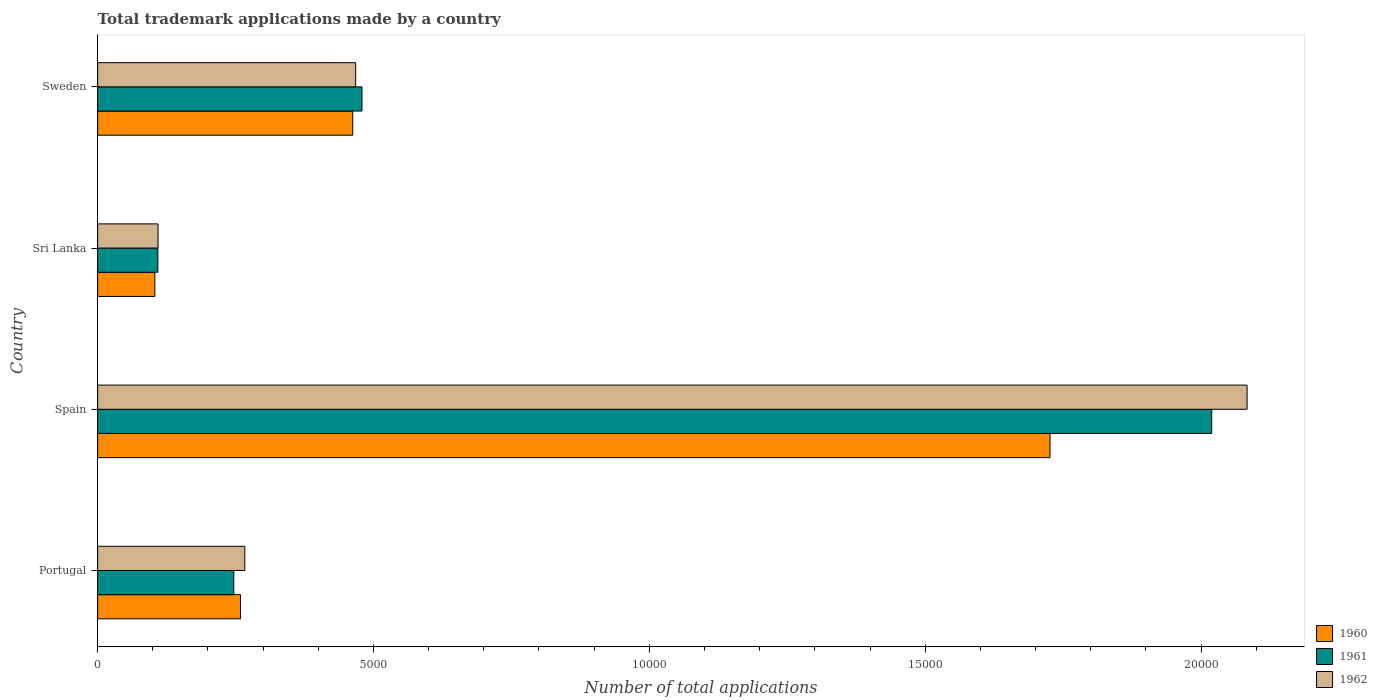Are the number of bars per tick equal to the number of legend labels?
Your response must be concise. Yes. In how many cases, is the number of bars for a given country not equal to the number of legend labels?
Offer a very short reply. 0. What is the number of applications made by in 1961 in Sweden?
Provide a succinct answer. 4792. Across all countries, what is the maximum number of applications made by in 1961?
Your response must be concise. 2.02e+04. Across all countries, what is the minimum number of applications made by in 1960?
Give a very brief answer. 1037. In which country was the number of applications made by in 1962 minimum?
Offer a terse response. Sri Lanka. What is the total number of applications made by in 1960 in the graph?
Your response must be concise. 2.55e+04. What is the difference between the number of applications made by in 1961 in Portugal and that in Sweden?
Keep it short and to the point. -2324. What is the difference between the number of applications made by in 1960 in Sri Lanka and the number of applications made by in 1961 in Spain?
Provide a succinct answer. -1.92e+04. What is the average number of applications made by in 1961 per country?
Offer a terse response. 7136.5. What is the difference between the number of applications made by in 1962 and number of applications made by in 1961 in Sri Lanka?
Provide a succinct answer. 3. What is the ratio of the number of applications made by in 1961 in Sri Lanka to that in Sweden?
Your response must be concise. 0.23. What is the difference between the highest and the second highest number of applications made by in 1962?
Make the answer very short. 1.62e+04. What is the difference between the highest and the lowest number of applications made by in 1962?
Give a very brief answer. 1.97e+04. In how many countries, is the number of applications made by in 1962 greater than the average number of applications made by in 1962 taken over all countries?
Offer a very short reply. 1. Is the sum of the number of applications made by in 1960 in Spain and Sweden greater than the maximum number of applications made by in 1961 across all countries?
Offer a terse response. Yes. How many bars are there?
Offer a terse response. 12. Are all the bars in the graph horizontal?
Provide a short and direct response. Yes. How many countries are there in the graph?
Your response must be concise. 4. Are the values on the major ticks of X-axis written in scientific E-notation?
Keep it short and to the point. No. Does the graph contain any zero values?
Your answer should be very brief. No. How many legend labels are there?
Make the answer very short. 3. What is the title of the graph?
Give a very brief answer. Total trademark applications made by a country. Does "2005" appear as one of the legend labels in the graph?
Your answer should be compact. No. What is the label or title of the X-axis?
Your answer should be very brief. Number of total applications. What is the Number of total applications in 1960 in Portugal?
Give a very brief answer. 2590. What is the Number of total applications of 1961 in Portugal?
Give a very brief answer. 2468. What is the Number of total applications of 1962 in Portugal?
Provide a short and direct response. 2668. What is the Number of total applications in 1960 in Spain?
Ensure brevity in your answer.  1.73e+04. What is the Number of total applications of 1961 in Spain?
Keep it short and to the point. 2.02e+04. What is the Number of total applications in 1962 in Spain?
Provide a short and direct response. 2.08e+04. What is the Number of total applications in 1960 in Sri Lanka?
Make the answer very short. 1037. What is the Number of total applications of 1961 in Sri Lanka?
Give a very brief answer. 1092. What is the Number of total applications in 1962 in Sri Lanka?
Your answer should be compact. 1095. What is the Number of total applications in 1960 in Sweden?
Offer a very short reply. 4624. What is the Number of total applications in 1961 in Sweden?
Offer a very short reply. 4792. What is the Number of total applications in 1962 in Sweden?
Keep it short and to the point. 4677. Across all countries, what is the maximum Number of total applications in 1960?
Your answer should be very brief. 1.73e+04. Across all countries, what is the maximum Number of total applications of 1961?
Your response must be concise. 2.02e+04. Across all countries, what is the maximum Number of total applications of 1962?
Offer a very short reply. 2.08e+04. Across all countries, what is the minimum Number of total applications of 1960?
Provide a short and direct response. 1037. Across all countries, what is the minimum Number of total applications of 1961?
Your answer should be very brief. 1092. Across all countries, what is the minimum Number of total applications in 1962?
Make the answer very short. 1095. What is the total Number of total applications of 1960 in the graph?
Offer a terse response. 2.55e+04. What is the total Number of total applications of 1961 in the graph?
Keep it short and to the point. 2.85e+04. What is the total Number of total applications in 1962 in the graph?
Your answer should be very brief. 2.93e+04. What is the difference between the Number of total applications of 1960 in Portugal and that in Spain?
Give a very brief answer. -1.47e+04. What is the difference between the Number of total applications in 1961 in Portugal and that in Spain?
Your response must be concise. -1.77e+04. What is the difference between the Number of total applications in 1962 in Portugal and that in Spain?
Make the answer very short. -1.82e+04. What is the difference between the Number of total applications in 1960 in Portugal and that in Sri Lanka?
Make the answer very short. 1553. What is the difference between the Number of total applications in 1961 in Portugal and that in Sri Lanka?
Ensure brevity in your answer.  1376. What is the difference between the Number of total applications of 1962 in Portugal and that in Sri Lanka?
Provide a succinct answer. 1573. What is the difference between the Number of total applications of 1960 in Portugal and that in Sweden?
Provide a succinct answer. -2034. What is the difference between the Number of total applications of 1961 in Portugal and that in Sweden?
Provide a succinct answer. -2324. What is the difference between the Number of total applications of 1962 in Portugal and that in Sweden?
Provide a succinct answer. -2009. What is the difference between the Number of total applications of 1960 in Spain and that in Sri Lanka?
Offer a terse response. 1.62e+04. What is the difference between the Number of total applications of 1961 in Spain and that in Sri Lanka?
Your answer should be very brief. 1.91e+04. What is the difference between the Number of total applications in 1962 in Spain and that in Sri Lanka?
Give a very brief answer. 1.97e+04. What is the difference between the Number of total applications in 1960 in Spain and that in Sweden?
Ensure brevity in your answer.  1.26e+04. What is the difference between the Number of total applications in 1961 in Spain and that in Sweden?
Offer a very short reply. 1.54e+04. What is the difference between the Number of total applications of 1962 in Spain and that in Sweden?
Your response must be concise. 1.62e+04. What is the difference between the Number of total applications in 1960 in Sri Lanka and that in Sweden?
Your answer should be very brief. -3587. What is the difference between the Number of total applications of 1961 in Sri Lanka and that in Sweden?
Your response must be concise. -3700. What is the difference between the Number of total applications of 1962 in Sri Lanka and that in Sweden?
Offer a terse response. -3582. What is the difference between the Number of total applications in 1960 in Portugal and the Number of total applications in 1961 in Spain?
Offer a terse response. -1.76e+04. What is the difference between the Number of total applications of 1960 in Portugal and the Number of total applications of 1962 in Spain?
Make the answer very short. -1.82e+04. What is the difference between the Number of total applications in 1961 in Portugal and the Number of total applications in 1962 in Spain?
Keep it short and to the point. -1.84e+04. What is the difference between the Number of total applications of 1960 in Portugal and the Number of total applications of 1961 in Sri Lanka?
Your answer should be compact. 1498. What is the difference between the Number of total applications of 1960 in Portugal and the Number of total applications of 1962 in Sri Lanka?
Give a very brief answer. 1495. What is the difference between the Number of total applications in 1961 in Portugal and the Number of total applications in 1962 in Sri Lanka?
Offer a very short reply. 1373. What is the difference between the Number of total applications in 1960 in Portugal and the Number of total applications in 1961 in Sweden?
Give a very brief answer. -2202. What is the difference between the Number of total applications in 1960 in Portugal and the Number of total applications in 1962 in Sweden?
Offer a very short reply. -2087. What is the difference between the Number of total applications in 1961 in Portugal and the Number of total applications in 1962 in Sweden?
Make the answer very short. -2209. What is the difference between the Number of total applications in 1960 in Spain and the Number of total applications in 1961 in Sri Lanka?
Make the answer very short. 1.62e+04. What is the difference between the Number of total applications of 1960 in Spain and the Number of total applications of 1962 in Sri Lanka?
Offer a very short reply. 1.62e+04. What is the difference between the Number of total applications in 1961 in Spain and the Number of total applications in 1962 in Sri Lanka?
Provide a short and direct response. 1.91e+04. What is the difference between the Number of total applications in 1960 in Spain and the Number of total applications in 1961 in Sweden?
Give a very brief answer. 1.25e+04. What is the difference between the Number of total applications of 1960 in Spain and the Number of total applications of 1962 in Sweden?
Make the answer very short. 1.26e+04. What is the difference between the Number of total applications of 1961 in Spain and the Number of total applications of 1962 in Sweden?
Keep it short and to the point. 1.55e+04. What is the difference between the Number of total applications of 1960 in Sri Lanka and the Number of total applications of 1961 in Sweden?
Your response must be concise. -3755. What is the difference between the Number of total applications in 1960 in Sri Lanka and the Number of total applications in 1962 in Sweden?
Your answer should be compact. -3640. What is the difference between the Number of total applications of 1961 in Sri Lanka and the Number of total applications of 1962 in Sweden?
Your answer should be very brief. -3585. What is the average Number of total applications of 1960 per country?
Your response must be concise. 6378.5. What is the average Number of total applications of 1961 per country?
Your response must be concise. 7136.5. What is the average Number of total applications in 1962 per country?
Your answer should be very brief. 7318.75. What is the difference between the Number of total applications in 1960 and Number of total applications in 1961 in Portugal?
Your response must be concise. 122. What is the difference between the Number of total applications of 1960 and Number of total applications of 1962 in Portugal?
Give a very brief answer. -78. What is the difference between the Number of total applications of 1961 and Number of total applications of 1962 in Portugal?
Your answer should be very brief. -200. What is the difference between the Number of total applications in 1960 and Number of total applications in 1961 in Spain?
Offer a very short reply. -2931. What is the difference between the Number of total applications of 1960 and Number of total applications of 1962 in Spain?
Your answer should be compact. -3572. What is the difference between the Number of total applications in 1961 and Number of total applications in 1962 in Spain?
Provide a short and direct response. -641. What is the difference between the Number of total applications in 1960 and Number of total applications in 1961 in Sri Lanka?
Provide a succinct answer. -55. What is the difference between the Number of total applications of 1960 and Number of total applications of 1962 in Sri Lanka?
Give a very brief answer. -58. What is the difference between the Number of total applications in 1960 and Number of total applications in 1961 in Sweden?
Provide a succinct answer. -168. What is the difference between the Number of total applications in 1960 and Number of total applications in 1962 in Sweden?
Offer a terse response. -53. What is the difference between the Number of total applications in 1961 and Number of total applications in 1962 in Sweden?
Your response must be concise. 115. What is the ratio of the Number of total applications of 1961 in Portugal to that in Spain?
Your answer should be compact. 0.12. What is the ratio of the Number of total applications of 1962 in Portugal to that in Spain?
Your answer should be compact. 0.13. What is the ratio of the Number of total applications in 1960 in Portugal to that in Sri Lanka?
Offer a very short reply. 2.5. What is the ratio of the Number of total applications of 1961 in Portugal to that in Sri Lanka?
Your response must be concise. 2.26. What is the ratio of the Number of total applications of 1962 in Portugal to that in Sri Lanka?
Ensure brevity in your answer.  2.44. What is the ratio of the Number of total applications of 1960 in Portugal to that in Sweden?
Provide a short and direct response. 0.56. What is the ratio of the Number of total applications in 1961 in Portugal to that in Sweden?
Make the answer very short. 0.52. What is the ratio of the Number of total applications in 1962 in Portugal to that in Sweden?
Keep it short and to the point. 0.57. What is the ratio of the Number of total applications of 1960 in Spain to that in Sri Lanka?
Offer a very short reply. 16.65. What is the ratio of the Number of total applications of 1961 in Spain to that in Sri Lanka?
Offer a very short reply. 18.49. What is the ratio of the Number of total applications in 1962 in Spain to that in Sri Lanka?
Make the answer very short. 19.03. What is the ratio of the Number of total applications of 1960 in Spain to that in Sweden?
Provide a succinct answer. 3.73. What is the ratio of the Number of total applications in 1961 in Spain to that in Sweden?
Your answer should be compact. 4.21. What is the ratio of the Number of total applications of 1962 in Spain to that in Sweden?
Ensure brevity in your answer.  4.45. What is the ratio of the Number of total applications of 1960 in Sri Lanka to that in Sweden?
Your response must be concise. 0.22. What is the ratio of the Number of total applications in 1961 in Sri Lanka to that in Sweden?
Make the answer very short. 0.23. What is the ratio of the Number of total applications in 1962 in Sri Lanka to that in Sweden?
Give a very brief answer. 0.23. What is the difference between the highest and the second highest Number of total applications of 1960?
Keep it short and to the point. 1.26e+04. What is the difference between the highest and the second highest Number of total applications in 1961?
Ensure brevity in your answer.  1.54e+04. What is the difference between the highest and the second highest Number of total applications in 1962?
Your answer should be very brief. 1.62e+04. What is the difference between the highest and the lowest Number of total applications of 1960?
Provide a succinct answer. 1.62e+04. What is the difference between the highest and the lowest Number of total applications of 1961?
Offer a very short reply. 1.91e+04. What is the difference between the highest and the lowest Number of total applications of 1962?
Offer a terse response. 1.97e+04. 